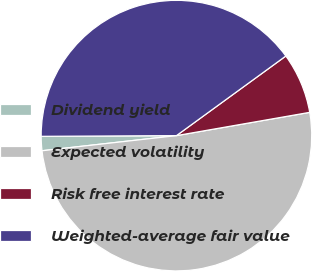<chart> <loc_0><loc_0><loc_500><loc_500><pie_chart><fcel>Dividend yield<fcel>Expected volatility<fcel>Risk free interest rate<fcel>Weighted-average fair value<nl><fcel>1.7%<fcel>50.97%<fcel>7.26%<fcel>40.07%<nl></chart> 